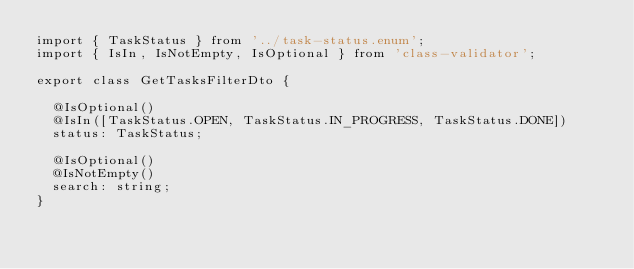<code> <loc_0><loc_0><loc_500><loc_500><_TypeScript_>import { TaskStatus } from '../task-status.enum';
import { IsIn, IsNotEmpty, IsOptional } from 'class-validator';

export class GetTasksFilterDto {

  @IsOptional()
  @IsIn([TaskStatus.OPEN, TaskStatus.IN_PROGRESS, TaskStatus.DONE])
  status: TaskStatus;

  @IsOptional()
  @IsNotEmpty()
  search: string;
}
</code> 